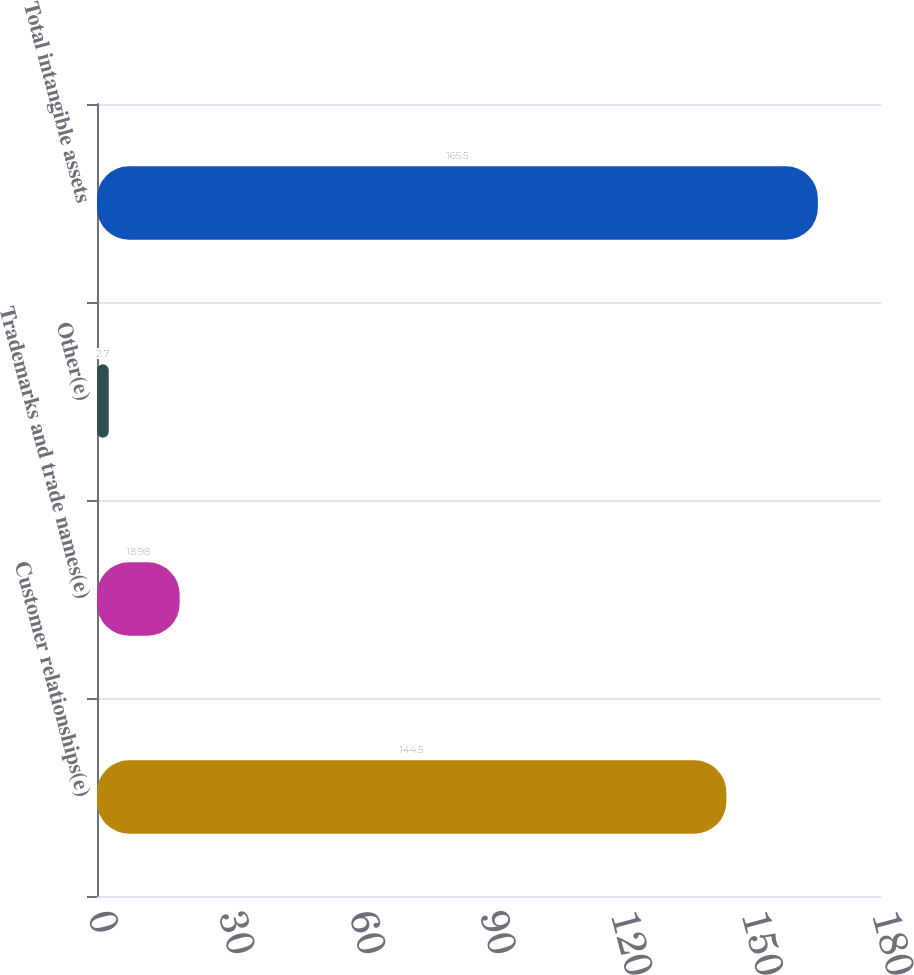<chart> <loc_0><loc_0><loc_500><loc_500><bar_chart><fcel>Customer relationships(e)<fcel>Trademarks and trade names(e)<fcel>Other(e)<fcel>Total intangible assets<nl><fcel>144.5<fcel>18.98<fcel>2.7<fcel>165.5<nl></chart> 